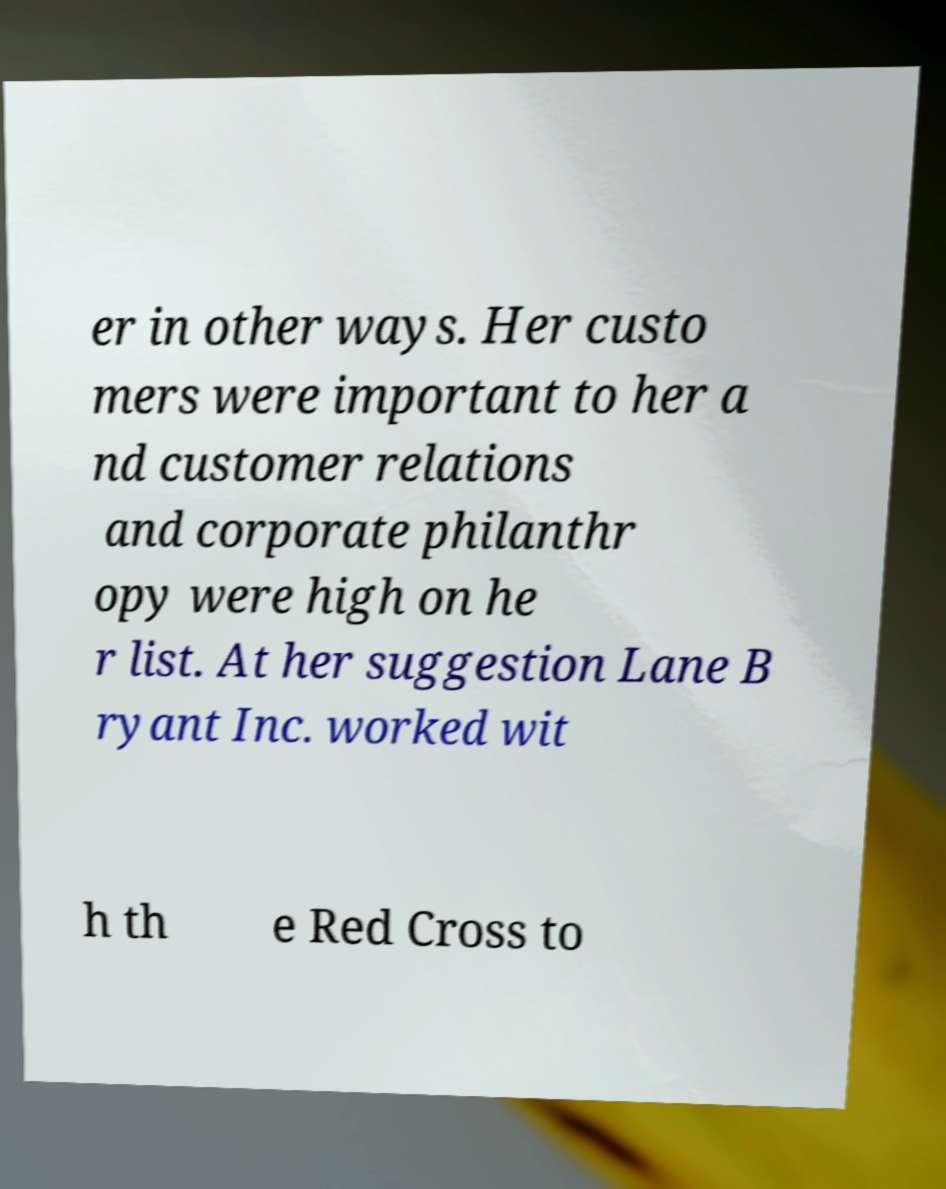Can you accurately transcribe the text from the provided image for me? er in other ways. Her custo mers were important to her a nd customer relations and corporate philanthr opy were high on he r list. At her suggestion Lane B ryant Inc. worked wit h th e Red Cross to 